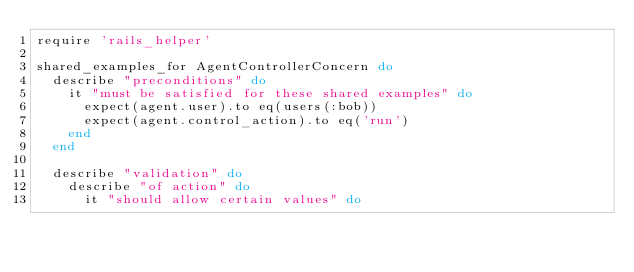Convert code to text. <code><loc_0><loc_0><loc_500><loc_500><_Ruby_>require 'rails_helper'

shared_examples_for AgentControllerConcern do
  describe "preconditions" do
    it "must be satisfied for these shared examples" do
      expect(agent.user).to eq(users(:bob))
      expect(agent.control_action).to eq('run')
    end
  end

  describe "validation" do
    describe "of action" do
      it "should allow certain values" do</code> 